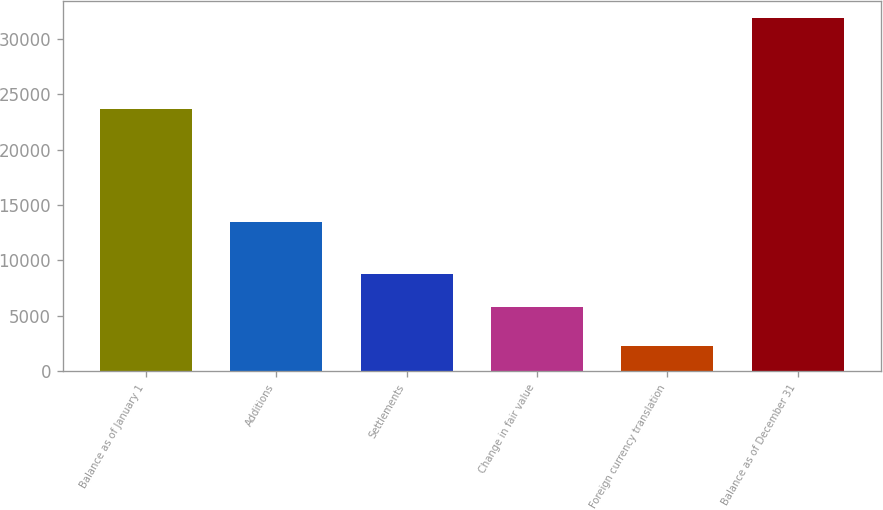Convert chart. <chart><loc_0><loc_0><loc_500><loc_500><bar_chart><fcel>Balance as of January 1<fcel>Additions<fcel>Settlements<fcel>Change in fair value<fcel>Foreign currency translation<fcel>Balance as of December 31<nl><fcel>23711<fcel>13474<fcel>8789<fcel>5743<fcel>2249<fcel>31890<nl></chart> 